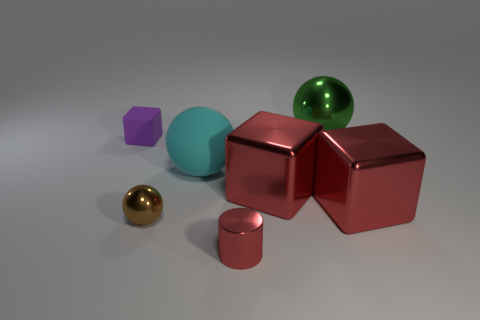Are there any spheres that are right of the matte thing that is right of the small purple block?
Give a very brief answer. Yes. Do the object behind the tiny matte block and the tiny brown shiny object have the same shape?
Give a very brief answer. Yes. What is the shape of the brown thing?
Make the answer very short. Sphere. What number of big red objects have the same material as the small block?
Provide a succinct answer. 0. There is a small metal cylinder; is it the same color as the object to the right of the green object?
Ensure brevity in your answer.  Yes. How many rubber objects are there?
Offer a terse response. 2. Is there a big metallic block of the same color as the small shiny cylinder?
Give a very brief answer. Yes. The tiny metallic thing that is behind the small cylinder that is to the right of the rubber object in front of the purple object is what color?
Keep it short and to the point. Brown. Does the tiny red cylinder have the same material as the big sphere on the left side of the green metallic object?
Your response must be concise. No. What material is the small purple cube?
Provide a succinct answer. Rubber. 